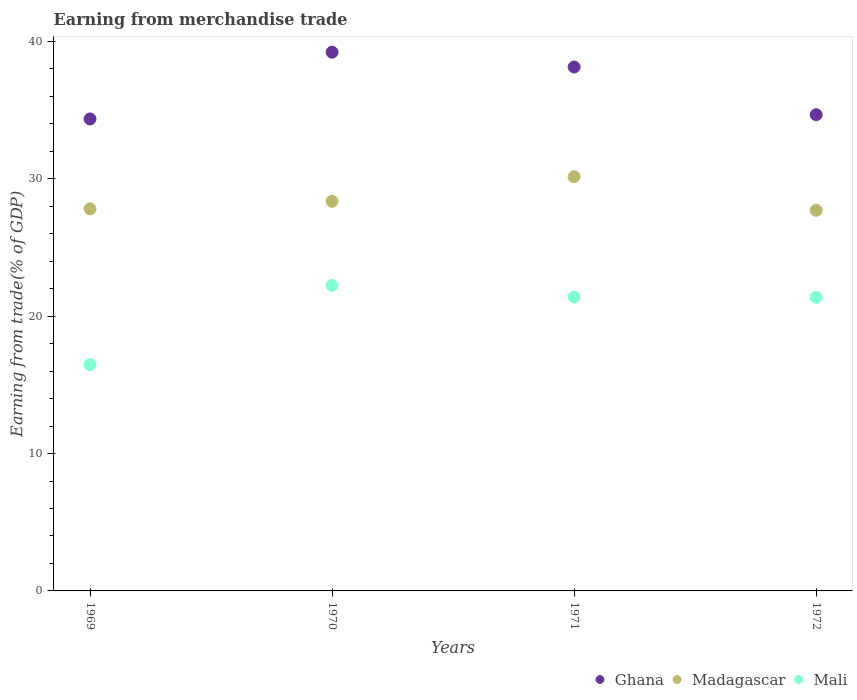Is the number of dotlines equal to the number of legend labels?
Keep it short and to the point. Yes. What is the earnings from trade in Ghana in 1971?
Offer a very short reply. 38.13. Across all years, what is the maximum earnings from trade in Ghana?
Keep it short and to the point. 39.21. Across all years, what is the minimum earnings from trade in Mali?
Your response must be concise. 16.47. In which year was the earnings from trade in Ghana maximum?
Keep it short and to the point. 1970. In which year was the earnings from trade in Madagascar minimum?
Offer a terse response. 1972. What is the total earnings from trade in Madagascar in the graph?
Keep it short and to the point. 114.02. What is the difference between the earnings from trade in Ghana in 1970 and that in 1972?
Offer a very short reply. 4.55. What is the difference between the earnings from trade in Madagascar in 1971 and the earnings from trade in Ghana in 1972?
Give a very brief answer. -4.51. What is the average earnings from trade in Madagascar per year?
Give a very brief answer. 28.51. In the year 1972, what is the difference between the earnings from trade in Ghana and earnings from trade in Madagascar?
Keep it short and to the point. 6.96. In how many years, is the earnings from trade in Ghana greater than 22 %?
Your answer should be compact. 4. What is the ratio of the earnings from trade in Madagascar in 1969 to that in 1971?
Your answer should be very brief. 0.92. Is the earnings from trade in Ghana in 1971 less than that in 1972?
Provide a short and direct response. No. Is the difference between the earnings from trade in Ghana in 1969 and 1972 greater than the difference between the earnings from trade in Madagascar in 1969 and 1972?
Provide a succinct answer. No. What is the difference between the highest and the second highest earnings from trade in Mali?
Provide a succinct answer. 0.85. What is the difference between the highest and the lowest earnings from trade in Ghana?
Ensure brevity in your answer.  4.86. Is the sum of the earnings from trade in Mali in 1969 and 1972 greater than the maximum earnings from trade in Madagascar across all years?
Provide a succinct answer. Yes. Is it the case that in every year, the sum of the earnings from trade in Madagascar and earnings from trade in Ghana  is greater than the earnings from trade in Mali?
Ensure brevity in your answer.  Yes. Does the earnings from trade in Madagascar monotonically increase over the years?
Offer a very short reply. No. What is the difference between two consecutive major ticks on the Y-axis?
Provide a short and direct response. 10. Does the graph contain any zero values?
Your response must be concise. No. How many legend labels are there?
Make the answer very short. 3. How are the legend labels stacked?
Keep it short and to the point. Horizontal. What is the title of the graph?
Offer a terse response. Earning from merchandise trade. Does "Kiribati" appear as one of the legend labels in the graph?
Your response must be concise. No. What is the label or title of the Y-axis?
Provide a short and direct response. Earning from trade(% of GDP). What is the Earning from trade(% of GDP) in Ghana in 1969?
Give a very brief answer. 34.35. What is the Earning from trade(% of GDP) of Madagascar in 1969?
Keep it short and to the point. 27.81. What is the Earning from trade(% of GDP) in Mali in 1969?
Your answer should be very brief. 16.47. What is the Earning from trade(% of GDP) of Ghana in 1970?
Your response must be concise. 39.21. What is the Earning from trade(% of GDP) in Madagascar in 1970?
Offer a very short reply. 28.36. What is the Earning from trade(% of GDP) in Mali in 1970?
Offer a terse response. 22.24. What is the Earning from trade(% of GDP) in Ghana in 1971?
Offer a terse response. 38.13. What is the Earning from trade(% of GDP) of Madagascar in 1971?
Give a very brief answer. 30.15. What is the Earning from trade(% of GDP) in Mali in 1971?
Offer a terse response. 21.39. What is the Earning from trade(% of GDP) in Ghana in 1972?
Offer a terse response. 34.66. What is the Earning from trade(% of GDP) of Madagascar in 1972?
Offer a terse response. 27.7. What is the Earning from trade(% of GDP) of Mali in 1972?
Make the answer very short. 21.37. Across all years, what is the maximum Earning from trade(% of GDP) of Ghana?
Make the answer very short. 39.21. Across all years, what is the maximum Earning from trade(% of GDP) of Madagascar?
Offer a very short reply. 30.15. Across all years, what is the maximum Earning from trade(% of GDP) in Mali?
Keep it short and to the point. 22.24. Across all years, what is the minimum Earning from trade(% of GDP) of Ghana?
Offer a terse response. 34.35. Across all years, what is the minimum Earning from trade(% of GDP) in Madagascar?
Your response must be concise. 27.7. Across all years, what is the minimum Earning from trade(% of GDP) of Mali?
Give a very brief answer. 16.47. What is the total Earning from trade(% of GDP) of Ghana in the graph?
Your answer should be compact. 146.36. What is the total Earning from trade(% of GDP) of Madagascar in the graph?
Make the answer very short. 114.02. What is the total Earning from trade(% of GDP) in Mali in the graph?
Keep it short and to the point. 81.47. What is the difference between the Earning from trade(% of GDP) of Ghana in 1969 and that in 1970?
Your response must be concise. -4.86. What is the difference between the Earning from trade(% of GDP) of Madagascar in 1969 and that in 1970?
Your answer should be very brief. -0.55. What is the difference between the Earning from trade(% of GDP) of Mali in 1969 and that in 1970?
Give a very brief answer. -5.76. What is the difference between the Earning from trade(% of GDP) in Ghana in 1969 and that in 1971?
Your answer should be compact. -3.78. What is the difference between the Earning from trade(% of GDP) of Madagascar in 1969 and that in 1971?
Provide a short and direct response. -2.34. What is the difference between the Earning from trade(% of GDP) in Mali in 1969 and that in 1971?
Your answer should be very brief. -4.92. What is the difference between the Earning from trade(% of GDP) in Ghana in 1969 and that in 1972?
Keep it short and to the point. -0.31. What is the difference between the Earning from trade(% of GDP) of Madagascar in 1969 and that in 1972?
Provide a short and direct response. 0.11. What is the difference between the Earning from trade(% of GDP) in Mali in 1969 and that in 1972?
Provide a short and direct response. -4.9. What is the difference between the Earning from trade(% of GDP) of Ghana in 1970 and that in 1971?
Ensure brevity in your answer.  1.08. What is the difference between the Earning from trade(% of GDP) in Madagascar in 1970 and that in 1971?
Make the answer very short. -1.79. What is the difference between the Earning from trade(% of GDP) in Mali in 1970 and that in 1971?
Provide a succinct answer. 0.85. What is the difference between the Earning from trade(% of GDP) in Ghana in 1970 and that in 1972?
Offer a very short reply. 4.55. What is the difference between the Earning from trade(% of GDP) of Madagascar in 1970 and that in 1972?
Provide a succinct answer. 0.66. What is the difference between the Earning from trade(% of GDP) in Mali in 1970 and that in 1972?
Provide a succinct answer. 0.86. What is the difference between the Earning from trade(% of GDP) of Ghana in 1971 and that in 1972?
Offer a terse response. 3.47. What is the difference between the Earning from trade(% of GDP) of Madagascar in 1971 and that in 1972?
Ensure brevity in your answer.  2.45. What is the difference between the Earning from trade(% of GDP) in Mali in 1971 and that in 1972?
Your answer should be very brief. 0.02. What is the difference between the Earning from trade(% of GDP) in Ghana in 1969 and the Earning from trade(% of GDP) in Madagascar in 1970?
Your answer should be very brief. 5.99. What is the difference between the Earning from trade(% of GDP) in Ghana in 1969 and the Earning from trade(% of GDP) in Mali in 1970?
Offer a terse response. 12.12. What is the difference between the Earning from trade(% of GDP) in Madagascar in 1969 and the Earning from trade(% of GDP) in Mali in 1970?
Keep it short and to the point. 5.57. What is the difference between the Earning from trade(% of GDP) in Ghana in 1969 and the Earning from trade(% of GDP) in Madagascar in 1971?
Offer a terse response. 4.2. What is the difference between the Earning from trade(% of GDP) of Ghana in 1969 and the Earning from trade(% of GDP) of Mali in 1971?
Your answer should be very brief. 12.96. What is the difference between the Earning from trade(% of GDP) of Madagascar in 1969 and the Earning from trade(% of GDP) of Mali in 1971?
Provide a succinct answer. 6.42. What is the difference between the Earning from trade(% of GDP) in Ghana in 1969 and the Earning from trade(% of GDP) in Madagascar in 1972?
Ensure brevity in your answer.  6.65. What is the difference between the Earning from trade(% of GDP) in Ghana in 1969 and the Earning from trade(% of GDP) in Mali in 1972?
Keep it short and to the point. 12.98. What is the difference between the Earning from trade(% of GDP) in Madagascar in 1969 and the Earning from trade(% of GDP) in Mali in 1972?
Provide a succinct answer. 6.44. What is the difference between the Earning from trade(% of GDP) of Ghana in 1970 and the Earning from trade(% of GDP) of Madagascar in 1971?
Ensure brevity in your answer.  9.06. What is the difference between the Earning from trade(% of GDP) in Ghana in 1970 and the Earning from trade(% of GDP) in Mali in 1971?
Keep it short and to the point. 17.82. What is the difference between the Earning from trade(% of GDP) of Madagascar in 1970 and the Earning from trade(% of GDP) of Mali in 1971?
Offer a terse response. 6.97. What is the difference between the Earning from trade(% of GDP) in Ghana in 1970 and the Earning from trade(% of GDP) in Madagascar in 1972?
Your answer should be very brief. 11.51. What is the difference between the Earning from trade(% of GDP) in Ghana in 1970 and the Earning from trade(% of GDP) in Mali in 1972?
Offer a very short reply. 17.84. What is the difference between the Earning from trade(% of GDP) in Madagascar in 1970 and the Earning from trade(% of GDP) in Mali in 1972?
Your answer should be compact. 6.99. What is the difference between the Earning from trade(% of GDP) in Ghana in 1971 and the Earning from trade(% of GDP) in Madagascar in 1972?
Provide a succinct answer. 10.43. What is the difference between the Earning from trade(% of GDP) in Ghana in 1971 and the Earning from trade(% of GDP) in Mali in 1972?
Provide a succinct answer. 16.76. What is the difference between the Earning from trade(% of GDP) in Madagascar in 1971 and the Earning from trade(% of GDP) in Mali in 1972?
Make the answer very short. 8.78. What is the average Earning from trade(% of GDP) of Ghana per year?
Your answer should be very brief. 36.59. What is the average Earning from trade(% of GDP) of Madagascar per year?
Make the answer very short. 28.51. What is the average Earning from trade(% of GDP) in Mali per year?
Offer a very short reply. 20.37. In the year 1969, what is the difference between the Earning from trade(% of GDP) of Ghana and Earning from trade(% of GDP) of Madagascar?
Your answer should be very brief. 6.54. In the year 1969, what is the difference between the Earning from trade(% of GDP) in Ghana and Earning from trade(% of GDP) in Mali?
Provide a succinct answer. 17.88. In the year 1969, what is the difference between the Earning from trade(% of GDP) in Madagascar and Earning from trade(% of GDP) in Mali?
Keep it short and to the point. 11.34. In the year 1970, what is the difference between the Earning from trade(% of GDP) in Ghana and Earning from trade(% of GDP) in Madagascar?
Keep it short and to the point. 10.85. In the year 1970, what is the difference between the Earning from trade(% of GDP) in Ghana and Earning from trade(% of GDP) in Mali?
Your answer should be compact. 16.98. In the year 1970, what is the difference between the Earning from trade(% of GDP) of Madagascar and Earning from trade(% of GDP) of Mali?
Your response must be concise. 6.12. In the year 1971, what is the difference between the Earning from trade(% of GDP) of Ghana and Earning from trade(% of GDP) of Madagascar?
Offer a very short reply. 7.98. In the year 1971, what is the difference between the Earning from trade(% of GDP) of Ghana and Earning from trade(% of GDP) of Mali?
Provide a succinct answer. 16.74. In the year 1971, what is the difference between the Earning from trade(% of GDP) in Madagascar and Earning from trade(% of GDP) in Mali?
Your response must be concise. 8.76. In the year 1972, what is the difference between the Earning from trade(% of GDP) of Ghana and Earning from trade(% of GDP) of Madagascar?
Make the answer very short. 6.96. In the year 1972, what is the difference between the Earning from trade(% of GDP) of Ghana and Earning from trade(% of GDP) of Mali?
Offer a very short reply. 13.29. In the year 1972, what is the difference between the Earning from trade(% of GDP) in Madagascar and Earning from trade(% of GDP) in Mali?
Ensure brevity in your answer.  6.33. What is the ratio of the Earning from trade(% of GDP) in Ghana in 1969 to that in 1970?
Provide a short and direct response. 0.88. What is the ratio of the Earning from trade(% of GDP) in Madagascar in 1969 to that in 1970?
Your answer should be compact. 0.98. What is the ratio of the Earning from trade(% of GDP) in Mali in 1969 to that in 1970?
Provide a short and direct response. 0.74. What is the ratio of the Earning from trade(% of GDP) in Ghana in 1969 to that in 1971?
Provide a succinct answer. 0.9. What is the ratio of the Earning from trade(% of GDP) of Madagascar in 1969 to that in 1971?
Make the answer very short. 0.92. What is the ratio of the Earning from trade(% of GDP) in Mali in 1969 to that in 1971?
Give a very brief answer. 0.77. What is the ratio of the Earning from trade(% of GDP) in Mali in 1969 to that in 1972?
Give a very brief answer. 0.77. What is the ratio of the Earning from trade(% of GDP) in Ghana in 1970 to that in 1971?
Make the answer very short. 1.03. What is the ratio of the Earning from trade(% of GDP) of Madagascar in 1970 to that in 1971?
Provide a succinct answer. 0.94. What is the ratio of the Earning from trade(% of GDP) of Mali in 1970 to that in 1971?
Provide a succinct answer. 1.04. What is the ratio of the Earning from trade(% of GDP) in Ghana in 1970 to that in 1972?
Ensure brevity in your answer.  1.13. What is the ratio of the Earning from trade(% of GDP) in Madagascar in 1970 to that in 1972?
Offer a terse response. 1.02. What is the ratio of the Earning from trade(% of GDP) in Mali in 1970 to that in 1972?
Your answer should be compact. 1.04. What is the ratio of the Earning from trade(% of GDP) of Ghana in 1971 to that in 1972?
Keep it short and to the point. 1.1. What is the ratio of the Earning from trade(% of GDP) of Madagascar in 1971 to that in 1972?
Your response must be concise. 1.09. What is the difference between the highest and the second highest Earning from trade(% of GDP) of Ghana?
Provide a succinct answer. 1.08. What is the difference between the highest and the second highest Earning from trade(% of GDP) in Madagascar?
Keep it short and to the point. 1.79. What is the difference between the highest and the second highest Earning from trade(% of GDP) of Mali?
Offer a very short reply. 0.85. What is the difference between the highest and the lowest Earning from trade(% of GDP) of Ghana?
Your answer should be very brief. 4.86. What is the difference between the highest and the lowest Earning from trade(% of GDP) of Madagascar?
Give a very brief answer. 2.45. What is the difference between the highest and the lowest Earning from trade(% of GDP) in Mali?
Your response must be concise. 5.76. 